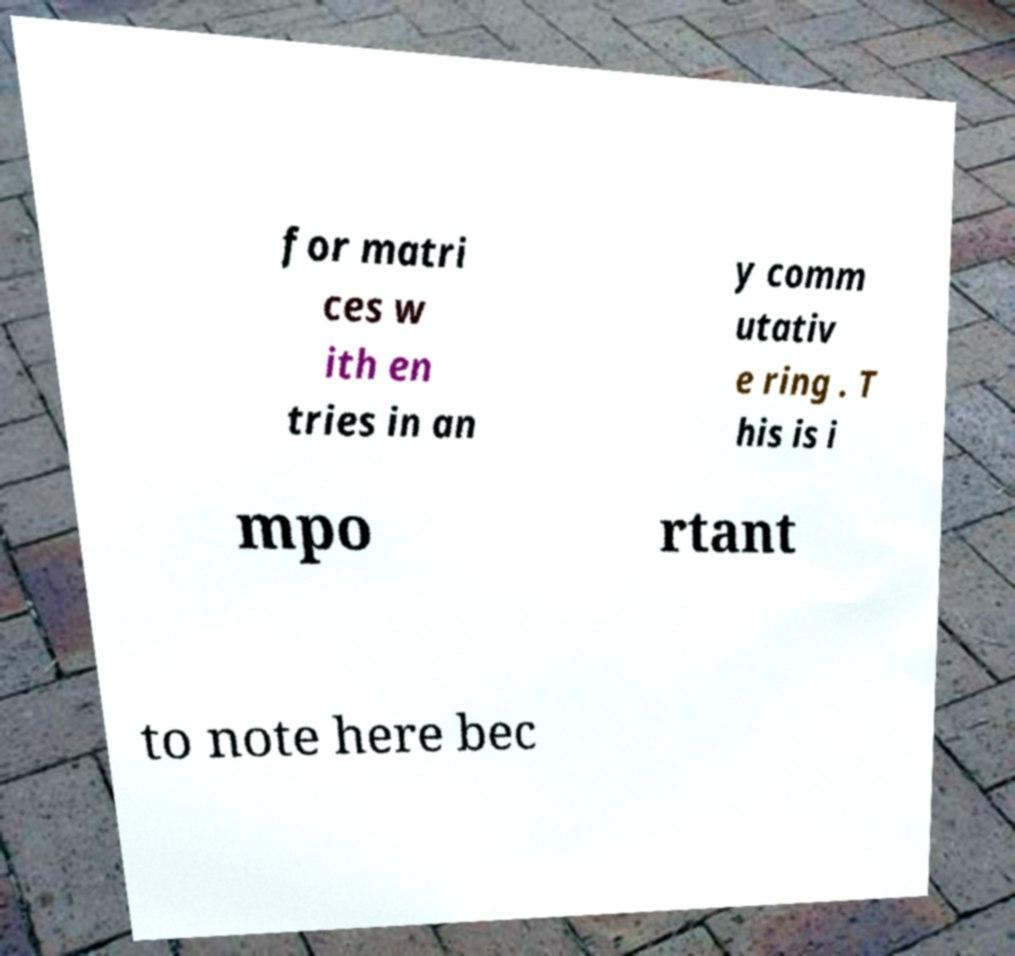For documentation purposes, I need the text within this image transcribed. Could you provide that? for matri ces w ith en tries in an y comm utativ e ring . T his is i mpo rtant to note here bec 